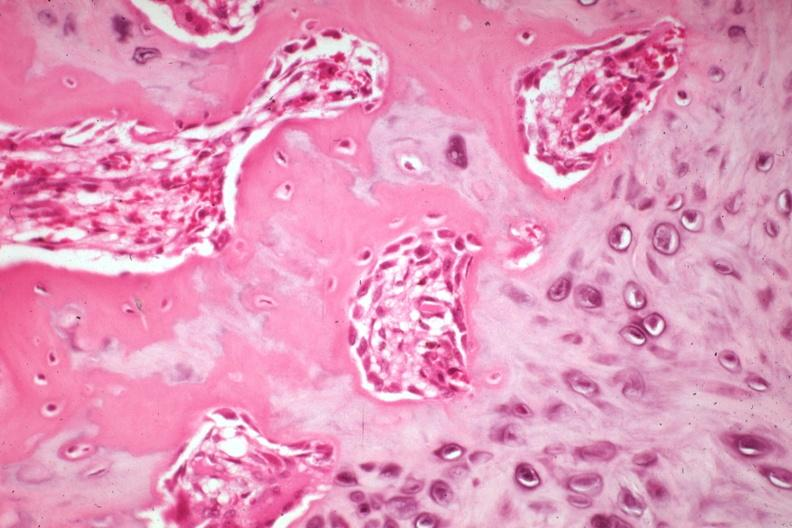does this image show high osteoid deposition with new bone formation and osteoblasts also cartilage excellent example case is a non-union?
Answer the question using a single word or phrase. Yes 